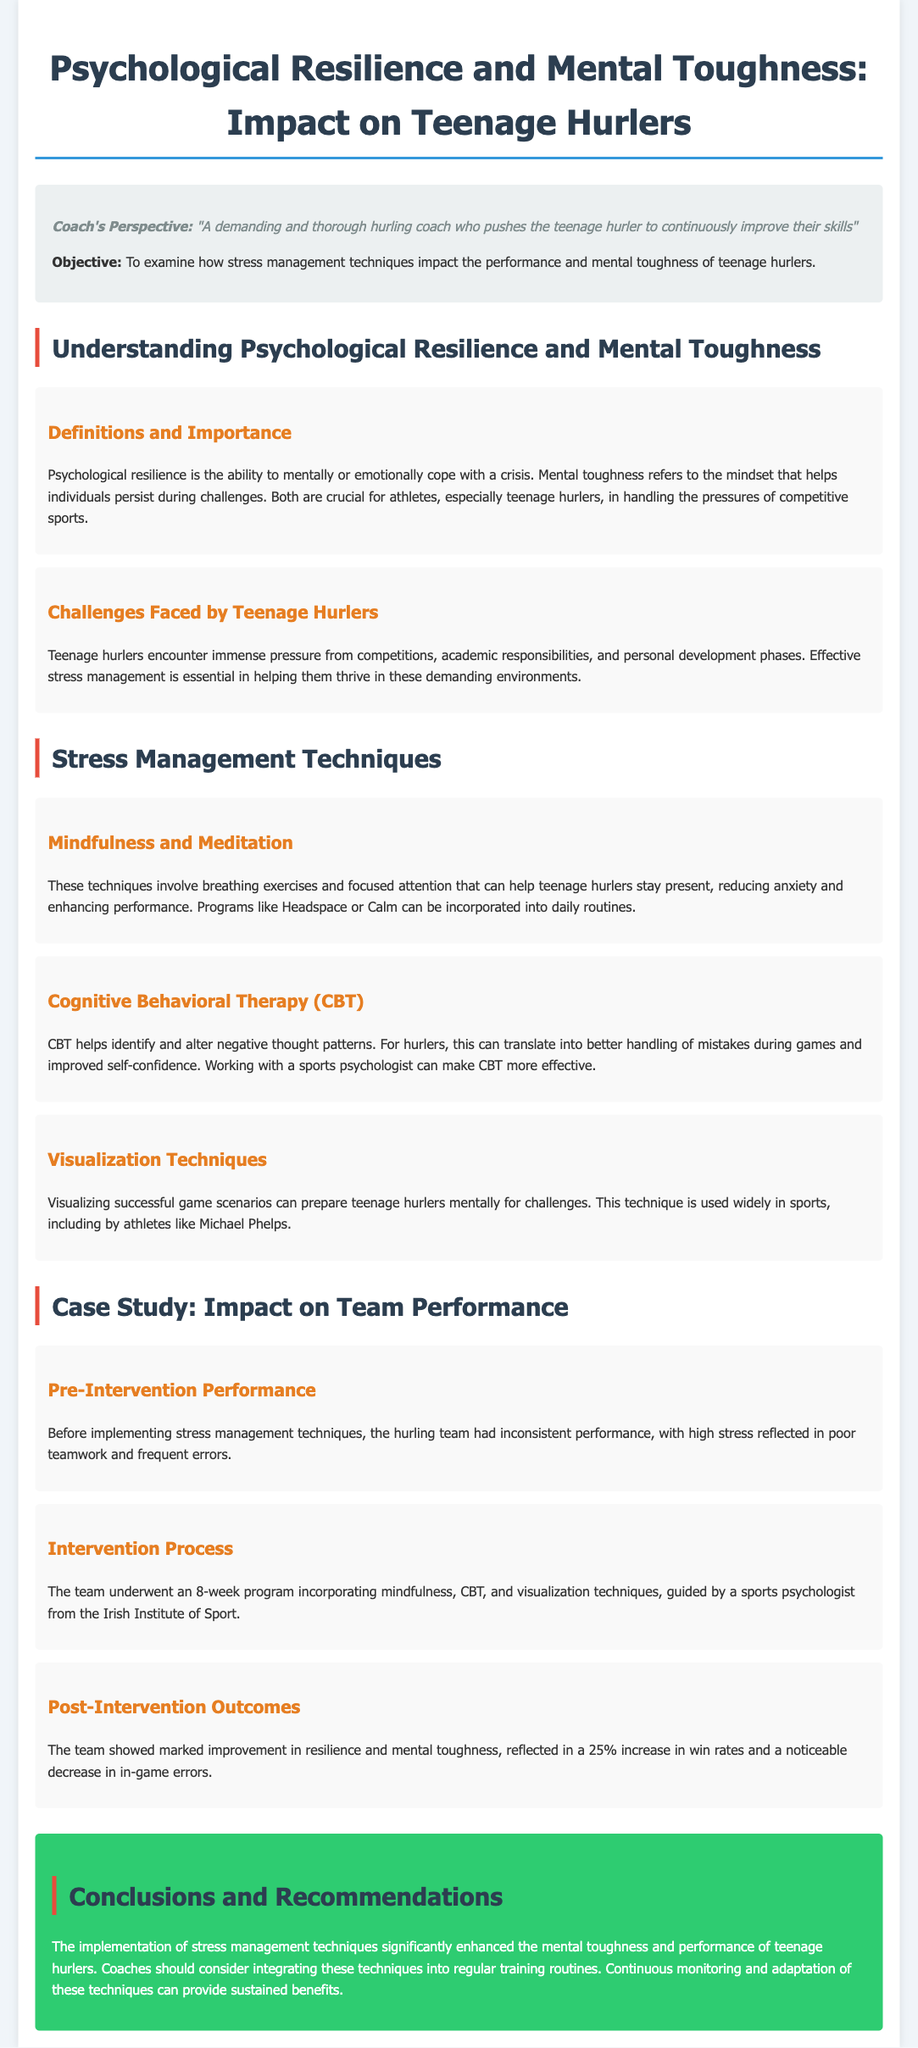what is the main objective of the study? The objective is to examine how stress management techniques impact the performance and mental toughness of teenage hurlers.
Answer: to examine how stress management techniques impact performance and mental toughness what are two stress management techniques mentioned? The document lists mindfulness and meditation, and cognitive behavioral therapy as stress management techniques.
Answer: mindfulness and meditation, cognitive behavioral therapy what was the percentage increase in win rates after the intervention? The post-intervention outcomes show a marked improvement, including a 25% increase in win rates.
Answer: 25% what challenges do teenage hurlers face? The challenges include immense pressure from competitions, academic responsibilities, and personal development phases.
Answer: immense pressure from competitions, academic responsibilities, and personal development phases who guided the intervention process? The intervention process was guided by a sports psychologist from the Irish Institute of Sport.
Answer: sports psychologist from the Irish Institute of Sport how long did the intervention program last? The document specifies that the intervention program lasted for 8 weeks.
Answer: 8 weeks what was the team's performance like before the intervention? Before the intervention, the team's performance was inconsistent, with high stress reflected in poor teamwork and frequent errors.
Answer: inconsistent performance with high stress what is one recommendation for coaches? Coaches should consider integrating stress management techniques into regular training routines.
Answer: integrate stress management techniques into regular training routines 